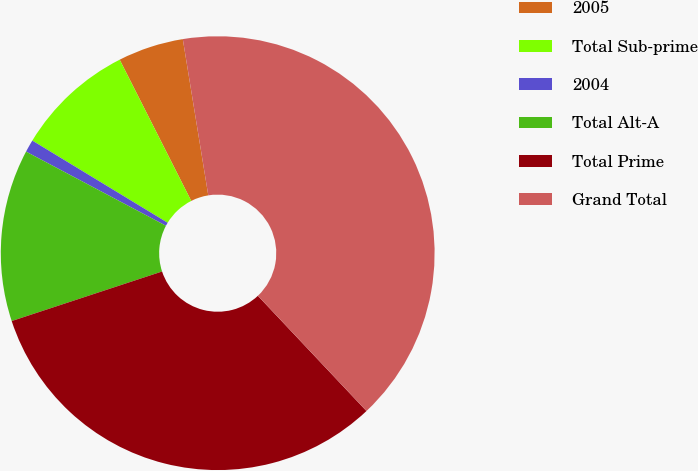Convert chart to OTSL. <chart><loc_0><loc_0><loc_500><loc_500><pie_chart><fcel>2005<fcel>Total Sub-prime<fcel>2004<fcel>Total Alt-A<fcel>Total Prime<fcel>Grand Total<nl><fcel>4.89%<fcel>8.85%<fcel>0.93%<fcel>12.82%<fcel>31.96%<fcel>40.54%<nl></chart> 